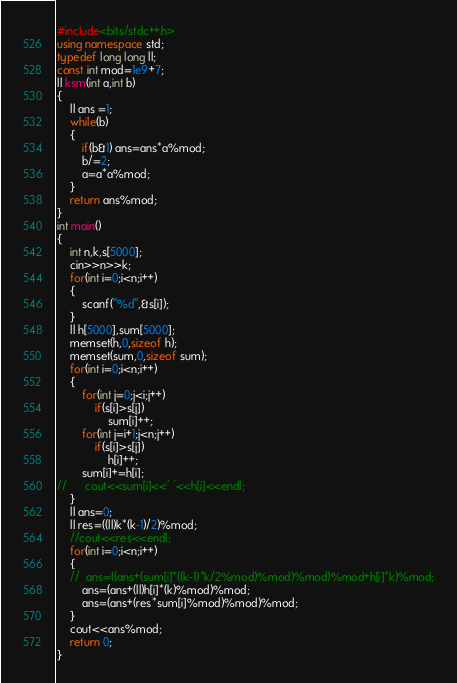<code> <loc_0><loc_0><loc_500><loc_500><_C++_>#include<bits/stdc++.h>
using namespace std;
typedef long long ll;
const int mod=1e9+7;
ll ksm(int a,int b)
{
	ll ans =1;
	while(b)
	{
		if(b&1) ans=ans*a%mod;
		b/=2;
		a=a*a%mod;
	}
	return ans%mod;
}
int main()
{
	int n,k,s[5000];
	cin>>n>>k;
	for(int i=0;i<n;i++)
	{
		scanf("%d",&s[i]);
	}
	ll h[5000],sum[5000];
	memset(h,0,sizeof h);
	memset(sum,0,sizeof sum);
	for(int i=0;i<n;i++)
	{
		for(int j=0;j<i;j++)
			if(s[i]>s[j])
				sum[i]++;
		for(int j=i+1;j<n;j++)
			if(s[i]>s[j])
				h[i]++;
		sum[i]+=h[i];
//		cout<<sum[i]<<' '<<h[i]<<endl;
	}
	ll ans=0;
	ll res=((ll)k*(k-1)/2)%mod;
	//cout<<res<<endl;
	for(int i=0;i<n;i++)
	{
	//	ans=((ans+(sum[i]*((k-1)*k/2%mod)%mod)%mod)%mod+h[i]*k)%mod;
		ans=(ans+(ll)h[i]*(k)%mod)%mod;
		ans=(ans+(res*sum[i]%mod)%mod)%mod;
	}
	cout<<ans%mod;
	return 0;
}</code> 